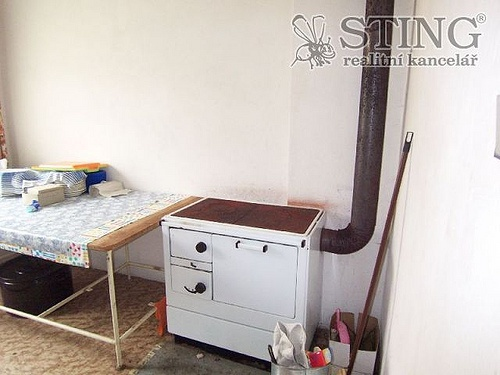Describe the objects in this image and their specific colors. I can see a dining table in darkgray, lightgray, tan, and gray tones in this image. 